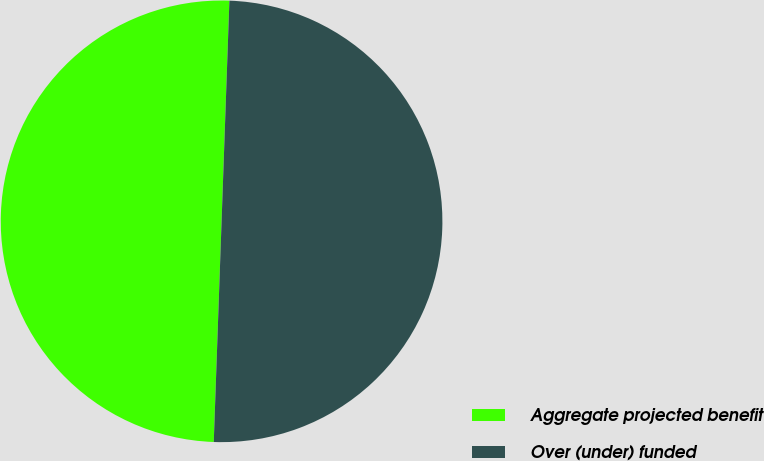<chart> <loc_0><loc_0><loc_500><loc_500><pie_chart><fcel>Aggregate projected benefit<fcel>Over (under) funded<nl><fcel>50.0%<fcel>50.0%<nl></chart> 